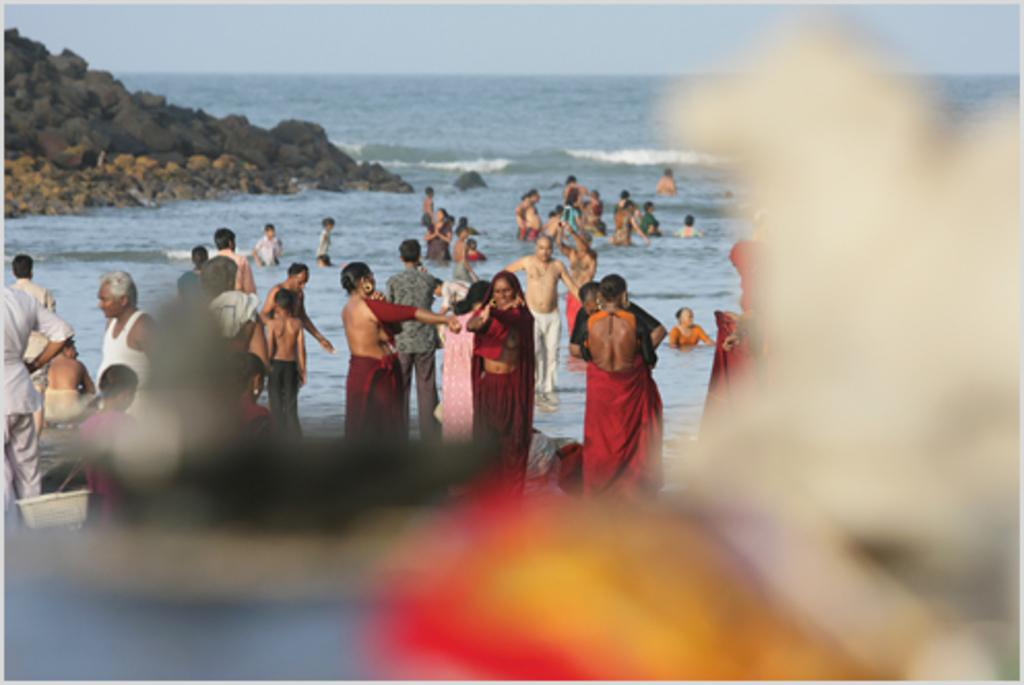How many people are in the image? There are many people in the image. What are some people doing in the image? Some people are in the water. What can be seen on the left side of the image? There are rocks on the left side of the image. What is visible in the background of the image? There is water and the sky visible in the background of the image. Are there any parts of the image that are not clear? Yes, some parts of the image are blurred. What type of dinner is being taught in the image? There is no dinner or teaching activity present in the image. 